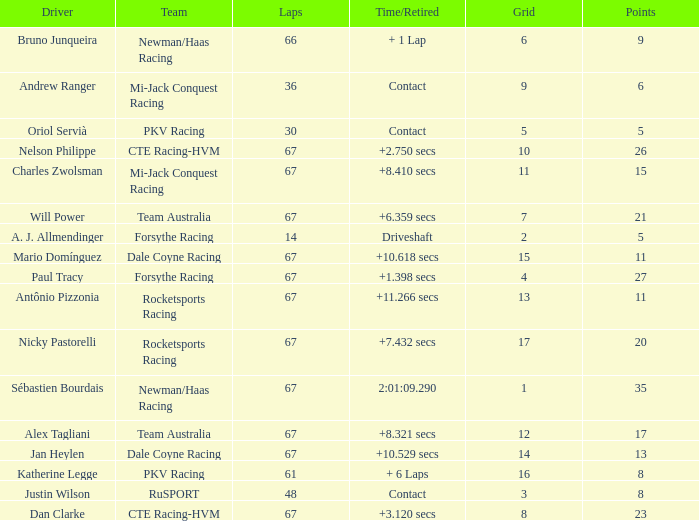How many average laps for Alex Tagliani with more than 17 points? None. 